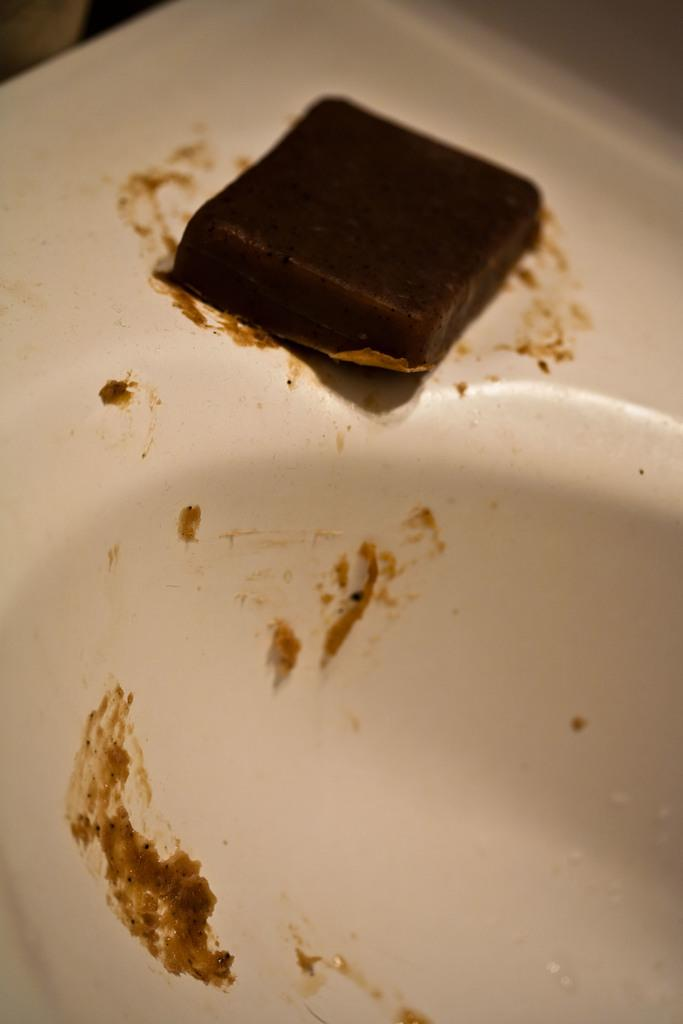What is located on the sink in the image? There is an object on the sink in the image. What type of land can be seen in the image? There is no land visible in the image, as it only features an object on the sink. What kind of wren is perched on the faucet in the image? There is no wren present in the image; it only features an object on the sink. 